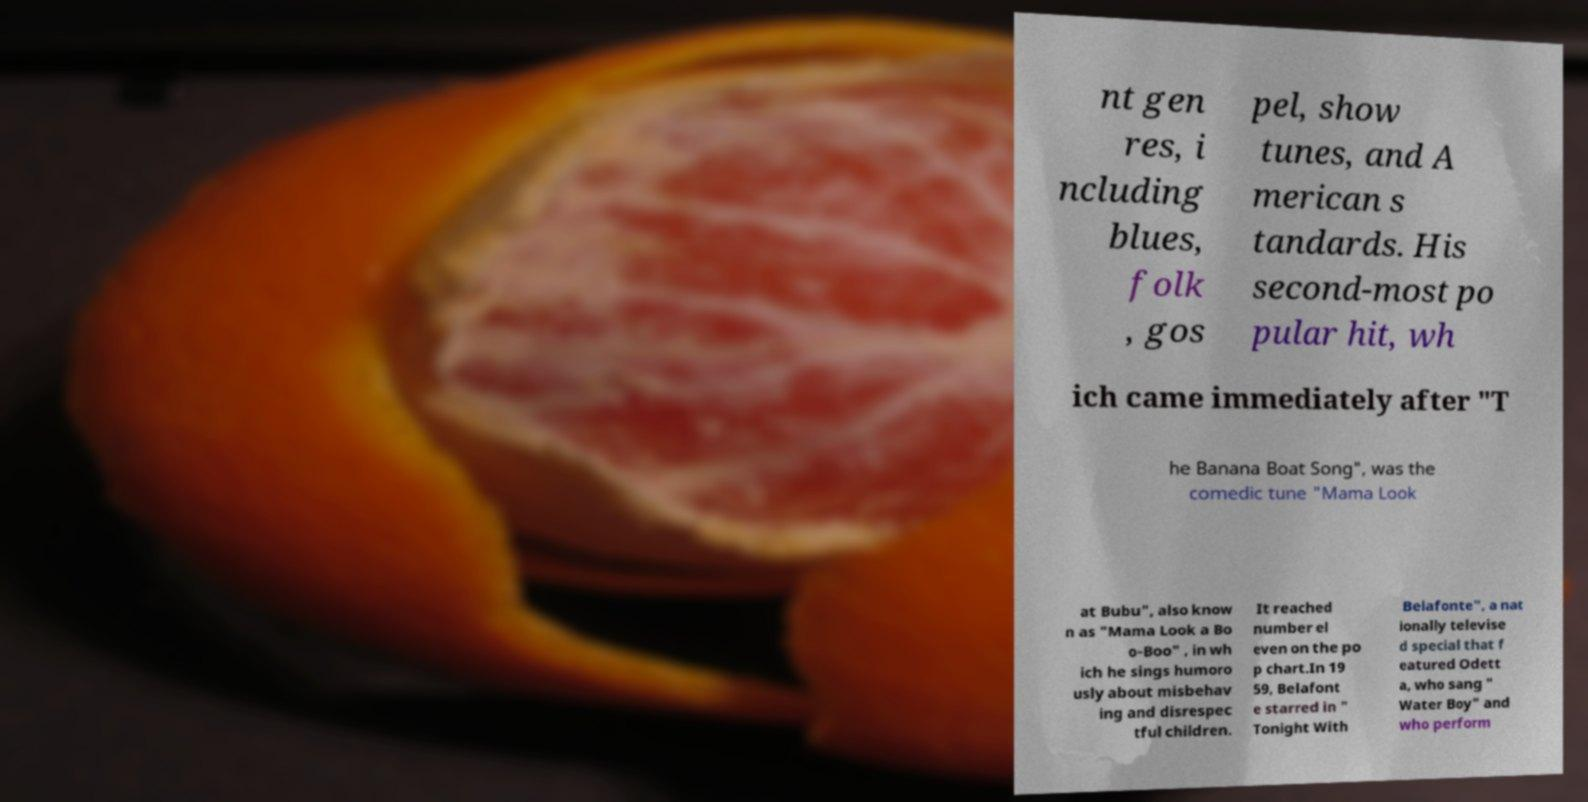There's text embedded in this image that I need extracted. Can you transcribe it verbatim? nt gen res, i ncluding blues, folk , gos pel, show tunes, and A merican s tandards. His second-most po pular hit, wh ich came immediately after "T he Banana Boat Song", was the comedic tune "Mama Look at Bubu", also know n as "Mama Look a Bo o-Boo" , in wh ich he sings humoro usly about misbehav ing and disrespec tful children. It reached number el even on the po p chart.In 19 59, Belafont e starred in " Tonight With Belafonte", a nat ionally televise d special that f eatured Odett a, who sang " Water Boy" and who perform 